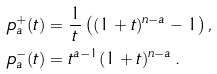<formula> <loc_0><loc_0><loc_500><loc_500>p _ { a } ^ { + } ( t ) & = \frac { 1 } { t } \left ( ( 1 + t ) ^ { n - a } - 1 \right ) , \\ p _ { a } ^ { - } ( t ) & = t ^ { a - 1 } ( 1 + t ) ^ { n - a } \, .</formula> 